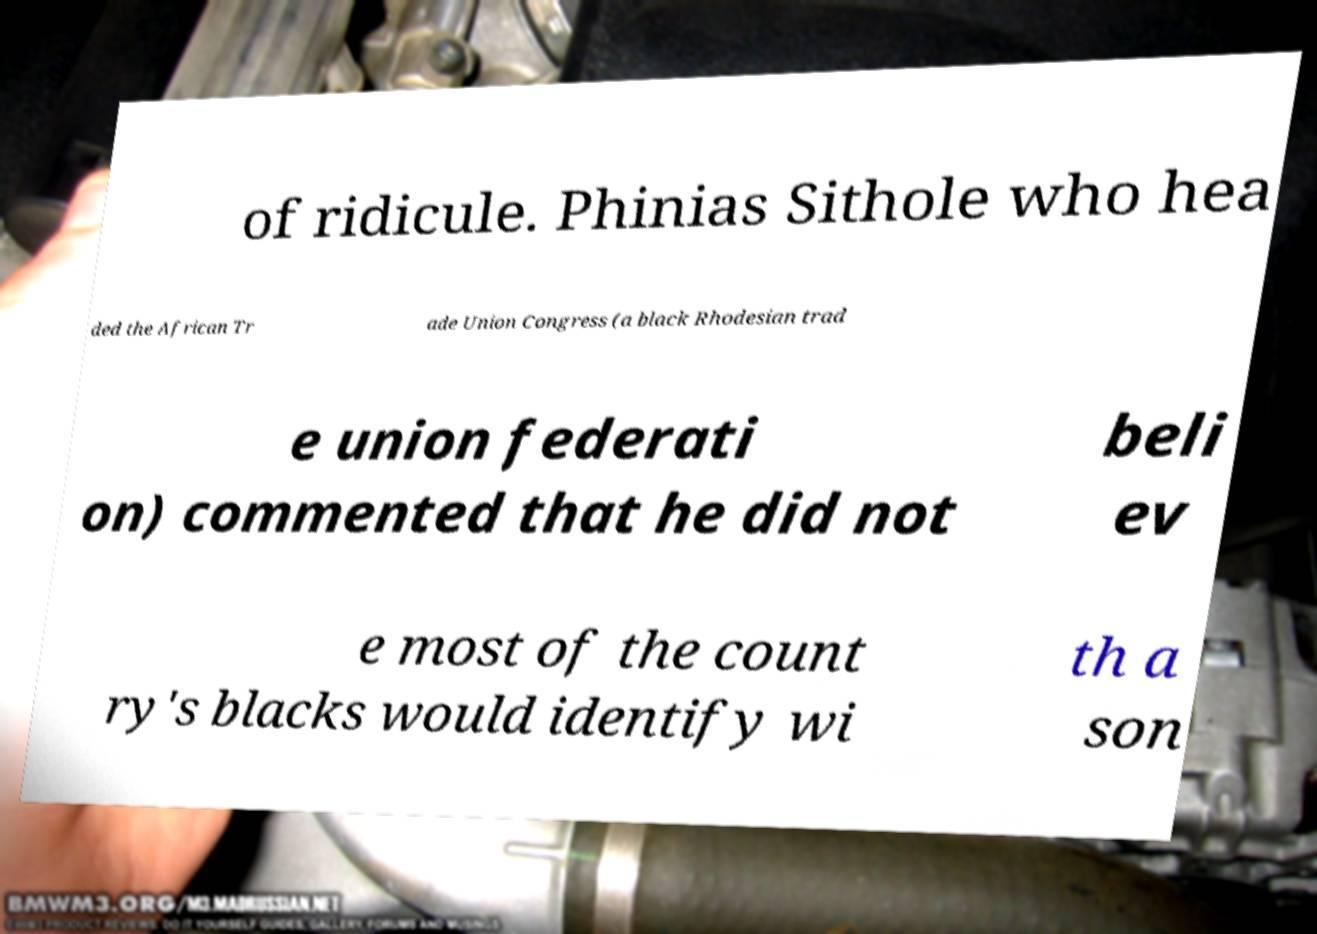Could you extract and type out the text from this image? of ridicule. Phinias Sithole who hea ded the African Tr ade Union Congress (a black Rhodesian trad e union federati on) commented that he did not beli ev e most of the count ry's blacks would identify wi th a son 